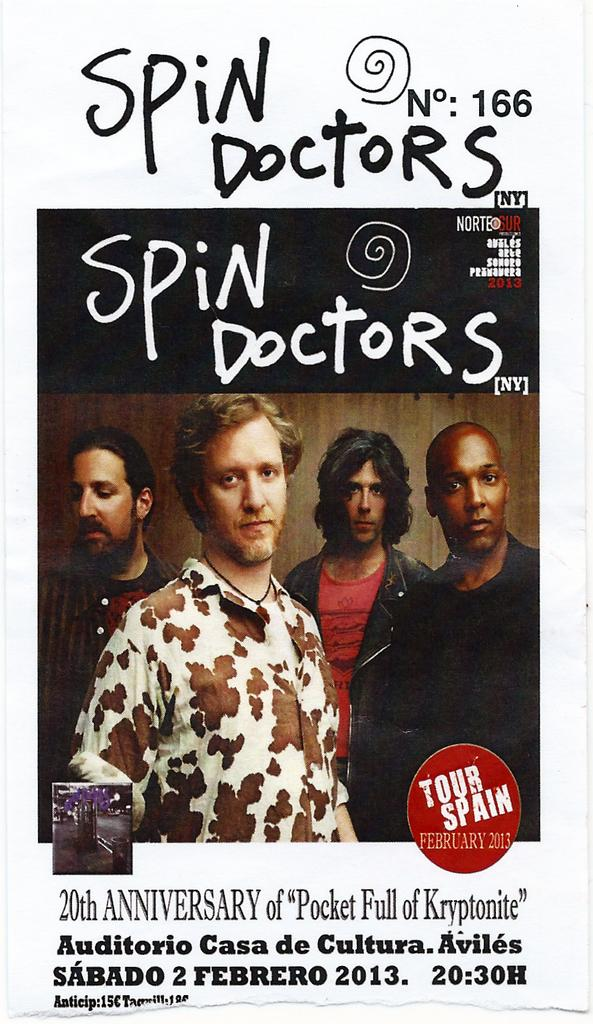<image>
Describe the image concisely. a spin doctors ad with some guys on it 